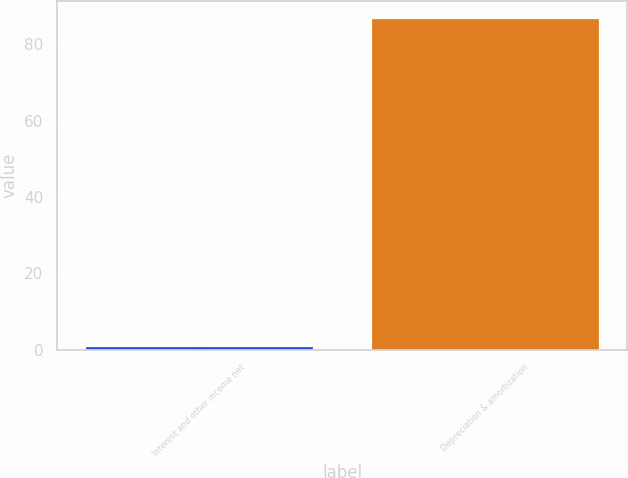<chart> <loc_0><loc_0><loc_500><loc_500><bar_chart><fcel>Interest and other income net<fcel>Depreciation & amortization<nl><fcel>1<fcel>87<nl></chart> 